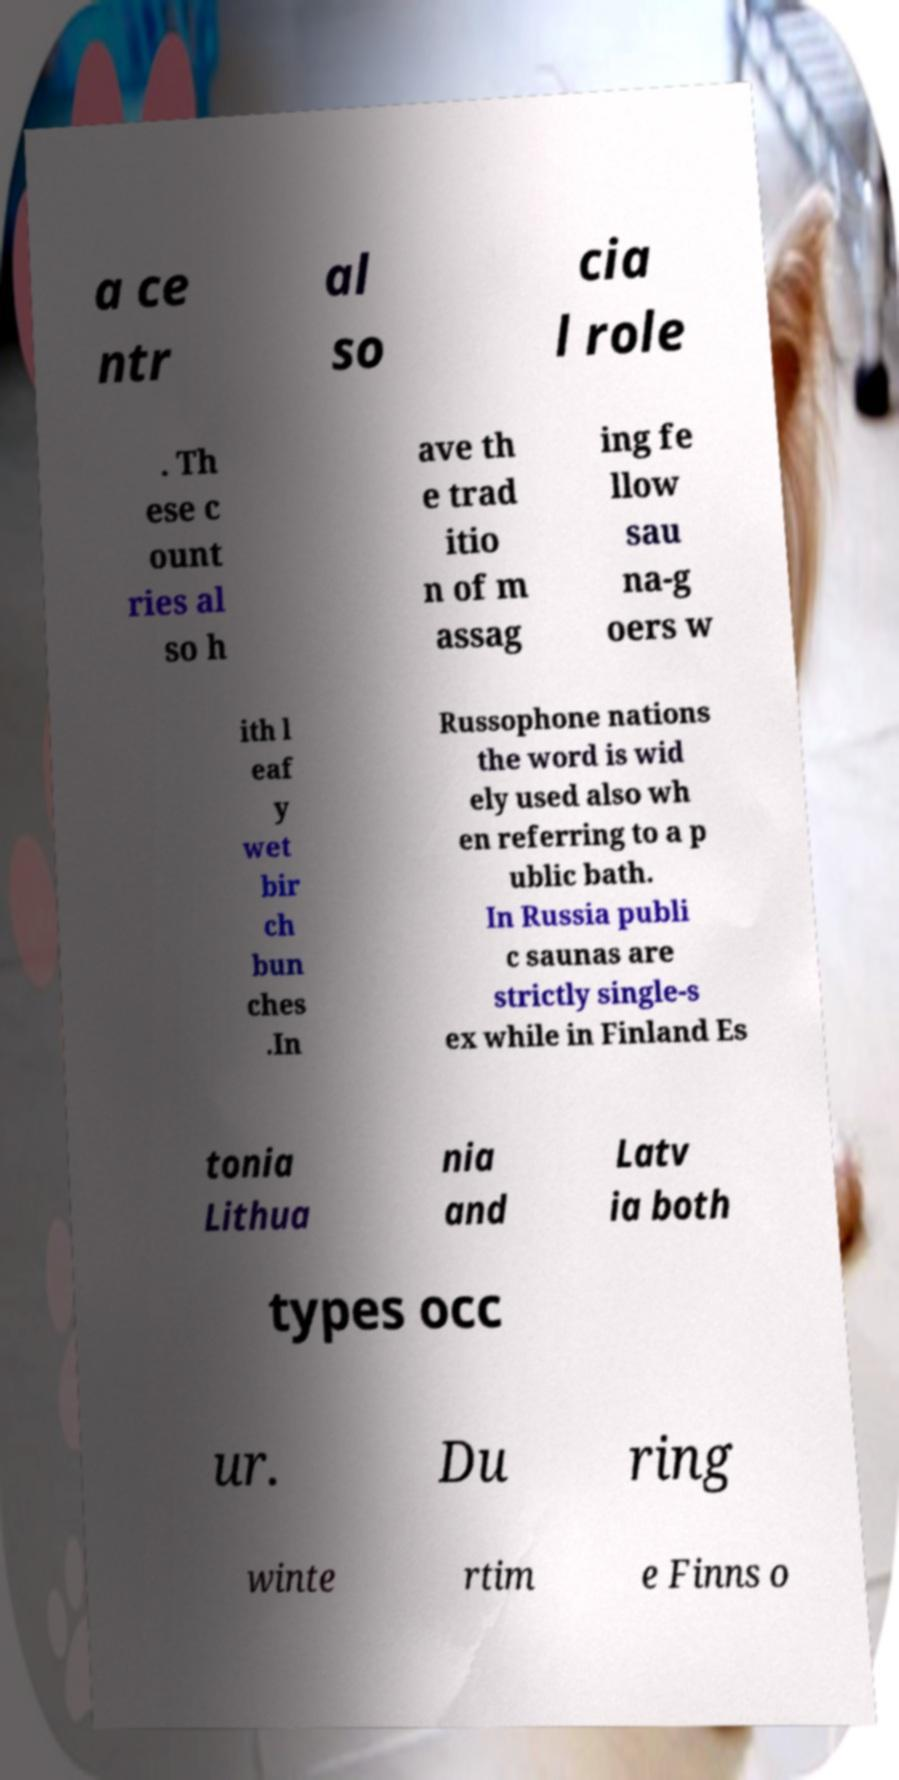There's text embedded in this image that I need extracted. Can you transcribe it verbatim? a ce ntr al so cia l role . Th ese c ount ries al so h ave th e trad itio n of m assag ing fe llow sau na-g oers w ith l eaf y wet bir ch bun ches .In Russophone nations the word is wid ely used also wh en referring to a p ublic bath. In Russia publi c saunas are strictly single-s ex while in Finland Es tonia Lithua nia and Latv ia both types occ ur. Du ring winte rtim e Finns o 